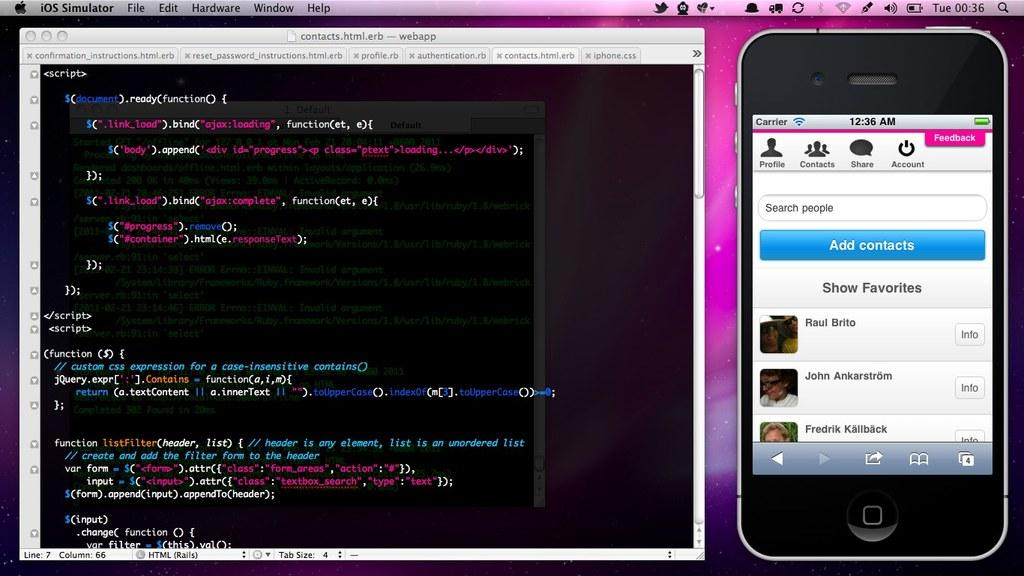<image>
Render a clear and concise summary of the photo. A computer screen shows a smart phone opened up to it's contacts and a web page to the left with page details written in code. 